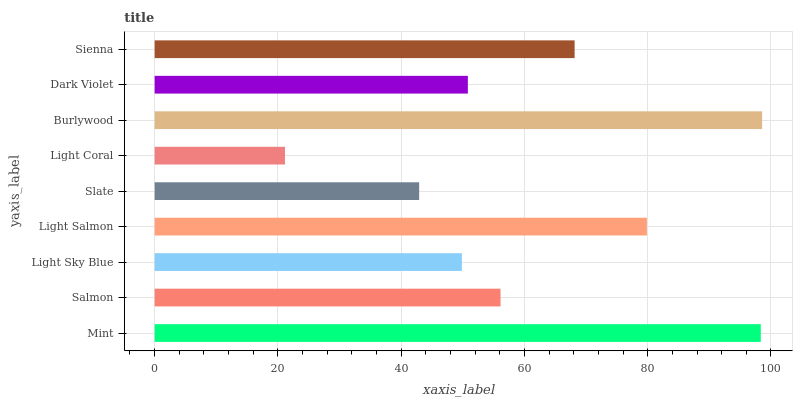Is Light Coral the minimum?
Answer yes or no. Yes. Is Burlywood the maximum?
Answer yes or no. Yes. Is Salmon the minimum?
Answer yes or no. No. Is Salmon the maximum?
Answer yes or no. No. Is Mint greater than Salmon?
Answer yes or no. Yes. Is Salmon less than Mint?
Answer yes or no. Yes. Is Salmon greater than Mint?
Answer yes or no. No. Is Mint less than Salmon?
Answer yes or no. No. Is Salmon the high median?
Answer yes or no. Yes. Is Salmon the low median?
Answer yes or no. Yes. Is Light Coral the high median?
Answer yes or no. No. Is Light Coral the low median?
Answer yes or no. No. 